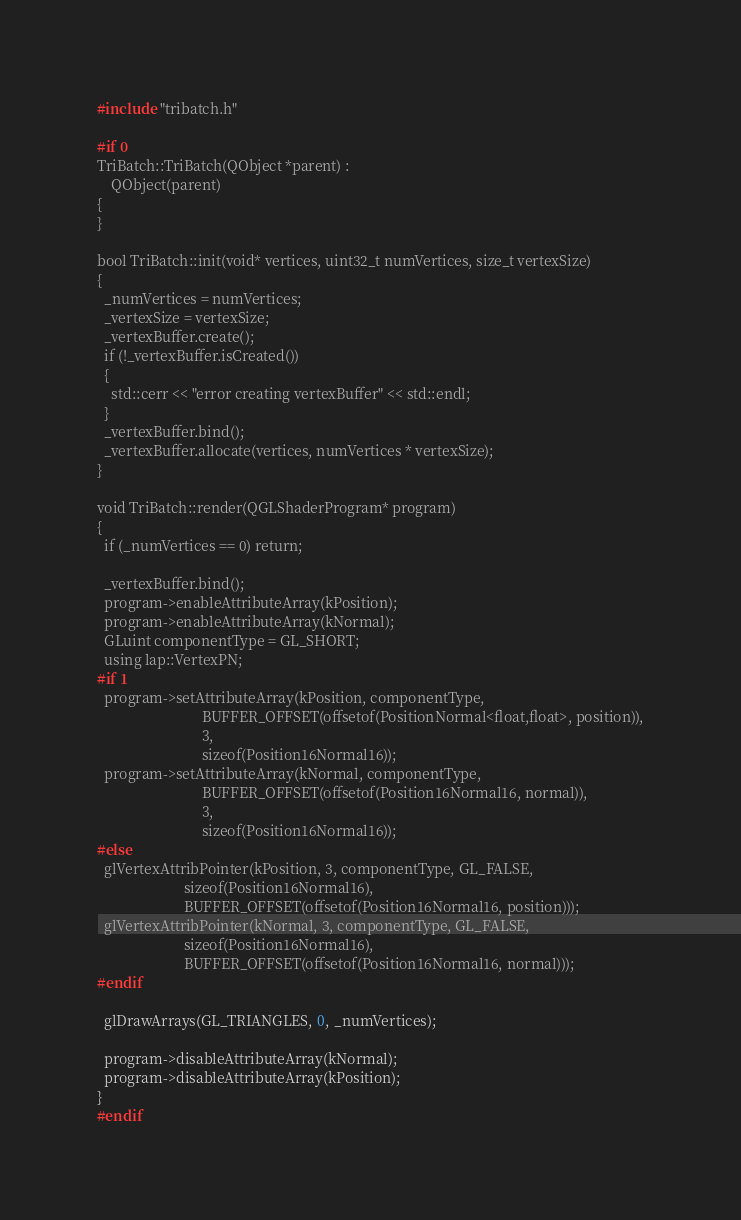Convert code to text. <code><loc_0><loc_0><loc_500><loc_500><_C++_>#include "tribatch.h"

#if 0
TriBatch::TriBatch(QObject *parent) :
    QObject(parent)
{
}

bool TriBatch::init(void* vertices, uint32_t numVertices, size_t vertexSize)
{
  _numVertices = numVertices;
  _vertexSize = vertexSize;
  _vertexBuffer.create();
  if (!_vertexBuffer.isCreated())
  {
    std::cerr << "error creating vertexBuffer" << std::endl;
  }
  _vertexBuffer.bind();
  _vertexBuffer.allocate(vertices, numVertices * vertexSize);
}

void TriBatch::render(QGLShaderProgram* program)
{
  if (_numVertices == 0) return;

  _vertexBuffer.bind();
  program->enableAttributeArray(kPosition);
  program->enableAttributeArray(kNormal);
  GLuint componentType = GL_SHORT;
  using lap::VertexPN;
#if 1
  program->setAttributeArray(kPosition, componentType,
                             BUFFER_OFFSET(offsetof(PositionNormal<float,float>, position)),
                             3,
                             sizeof(Position16Normal16));
  program->setAttributeArray(kNormal, componentType,
                             BUFFER_OFFSET(offsetof(Position16Normal16, normal)),
                             3,
                             sizeof(Position16Normal16));
#else
  glVertexAttribPointer(kPosition, 3, componentType, GL_FALSE,
                        sizeof(Position16Normal16),
                        BUFFER_OFFSET(offsetof(Position16Normal16, position)));
  glVertexAttribPointer(kNormal, 3, componentType, GL_FALSE,
                        sizeof(Position16Normal16),
                        BUFFER_OFFSET(offsetof(Position16Normal16, normal)));
#endif

  glDrawArrays(GL_TRIANGLES, 0, _numVertices);

  program->disableAttributeArray(kNormal);
  program->disableAttributeArray(kPosition);
}
#endif
</code> 